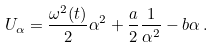<formula> <loc_0><loc_0><loc_500><loc_500>U _ { \alpha } = \frac { \omega ^ { 2 } ( t ) } { 2 } \alpha ^ { 2 } + \frac { a } { 2 } \frac { 1 } { \alpha ^ { 2 } } - b \alpha \, .</formula> 